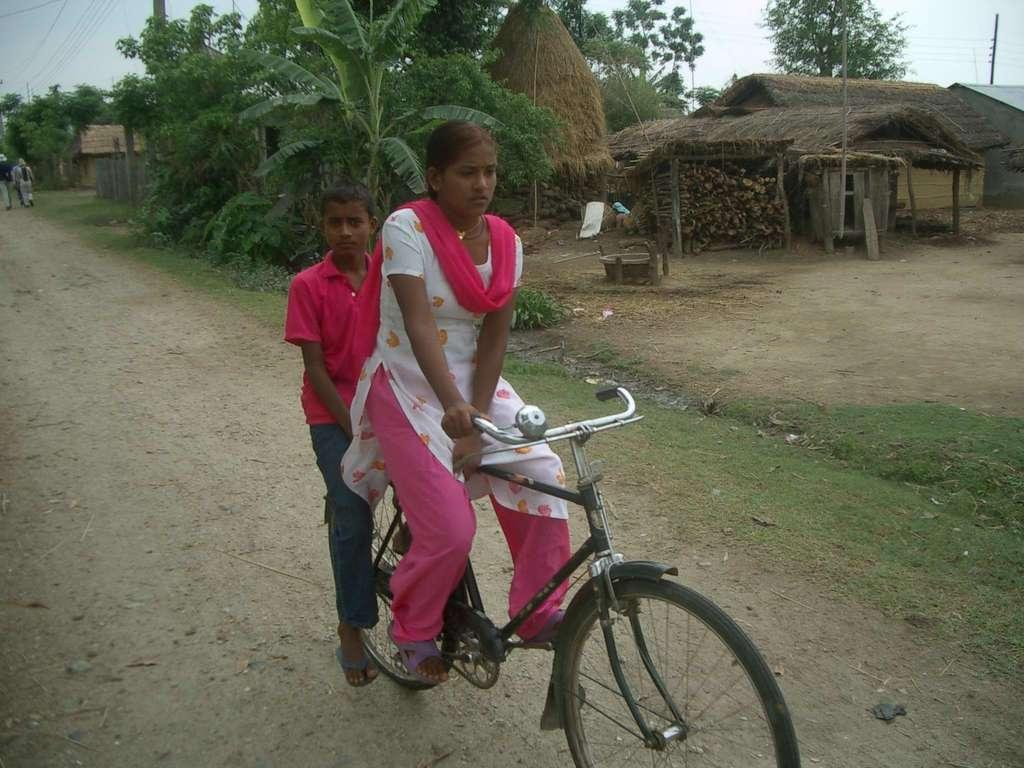Who is the main subject in the image? There is a woman in the image. What is the woman doing in the image? The woman is riding a bicycle. Is there anyone else in the image? Yes, there is a boy in the image. What is the boy doing in the image? The boy is on the bicycle with the woman. What can be seen in the background of the image? There are trees, people, the sky, and a road in the background of the image. Can you see any jellyfish swimming in the sky in the image? No, there are no jellyfish present in the image. Is there a fireman putting out a fire in the background of the image? No, there is no fireman or fire in the image. 